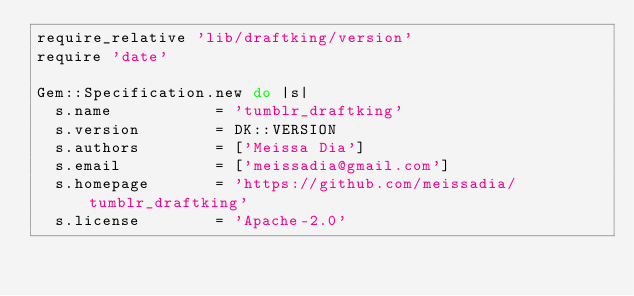Convert code to text. <code><loc_0><loc_0><loc_500><loc_500><_Ruby_>require_relative 'lib/draftking/version'
require 'date'

Gem::Specification.new do |s|
  s.name           = 'tumblr_draftking'
  s.version        = DK::VERSION
  s.authors        = ['Meissa Dia']
  s.email          = ['meissadia@gmail.com']
  s.homepage       = 'https://github.com/meissadia/tumblr_draftking'
  s.license        = 'Apache-2.0'</code> 